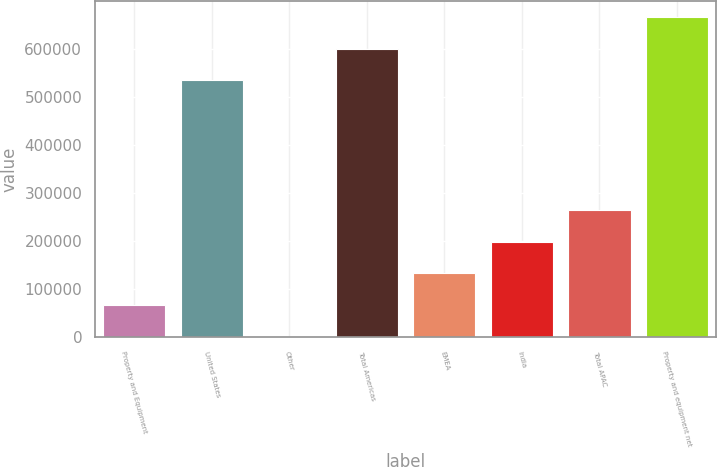<chart> <loc_0><loc_0><loc_500><loc_500><bar_chart><fcel>Property and Equipment<fcel>United States<fcel>Other<fcel>Total Americas<fcel>EMEA<fcel>India<fcel>Total APAC<fcel>Property and equipment net<nl><fcel>67120.4<fcel>533792<fcel>1270<fcel>599642<fcel>132971<fcel>198821<fcel>264672<fcel>665493<nl></chart> 